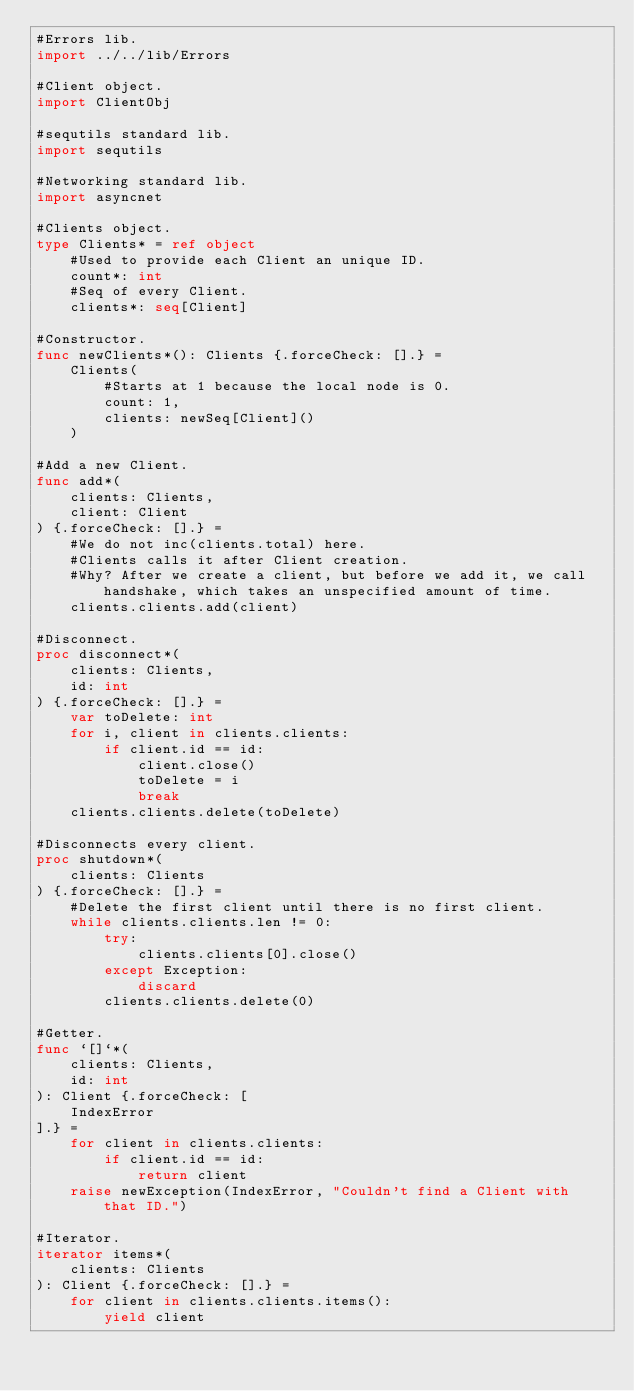<code> <loc_0><loc_0><loc_500><loc_500><_Nim_>#Errors lib.
import ../../lib/Errors

#Client object.
import ClientObj

#sequtils standard lib.
import sequtils

#Networking standard lib.
import asyncnet

#Clients object.
type Clients* = ref object
    #Used to provide each Client an unique ID.
    count*: int
    #Seq of every Client.
    clients*: seq[Client]

#Constructor.
func newClients*(): Clients {.forceCheck: [].} =
    Clients(
        #Starts at 1 because the local node is 0.
        count: 1,
        clients: newSeq[Client]()
    )

#Add a new Client.
func add*(
    clients: Clients,
    client: Client
) {.forceCheck: [].} =
    #We do not inc(clients.total) here.
    #Clients calls it after Client creation.
    #Why? After we create a client, but before we add it, we call handshake, which takes an unspecified amount of time.
    clients.clients.add(client)

#Disconnect.
proc disconnect*(
    clients: Clients,
    id: int
) {.forceCheck: [].} =
    var toDelete: int
    for i, client in clients.clients:
        if client.id == id:
            client.close()
            toDelete = i
            break
    clients.clients.delete(toDelete)

#Disconnects every client.
proc shutdown*(
    clients: Clients
) {.forceCheck: [].} =
    #Delete the first client until there is no first client.
    while clients.clients.len != 0:
        try:
            clients.clients[0].close()
        except Exception:
            discard
        clients.clients.delete(0)

#Getter.
func `[]`*(
    clients: Clients,
    id: int
): Client {.forceCheck: [
    IndexError
].} =
    for client in clients.clients:
        if client.id == id:
            return client
    raise newException(IndexError, "Couldn't find a Client with that ID.")

#Iterator.
iterator items*(
    clients: Clients
): Client {.forceCheck: [].} =
    for client in clients.clients.items():
        yield client
</code> 